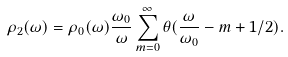Convert formula to latex. <formula><loc_0><loc_0><loc_500><loc_500>\rho _ { 2 } ( \omega ) = \rho _ { 0 } ( \omega ) \frac { \omega _ { 0 } } { \omega } \sum _ { m = 0 } ^ { \infty } \theta ( \frac { \omega } { \omega _ { 0 } } - m + 1 / 2 ) .</formula> 